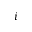<formula> <loc_0><loc_0><loc_500><loc_500>i</formula> 